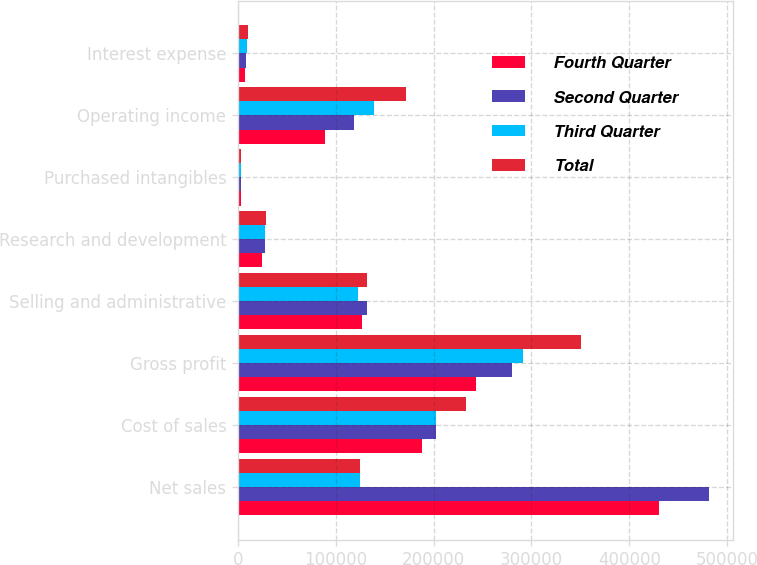<chart> <loc_0><loc_0><loc_500><loc_500><stacked_bar_chart><ecel><fcel>Net sales<fcel>Cost of sales<fcel>Gross profit<fcel>Selling and administrative<fcel>Research and development<fcel>Purchased intangibles<fcel>Operating income<fcel>Interest expense<nl><fcel>Fourth Quarter<fcel>430508<fcel>187719<fcel>242789<fcel>126635<fcel>24746<fcel>2647<fcel>88761<fcel>7489<nl><fcel>Second Quarter<fcel>481801<fcel>201853<fcel>279948<fcel>131930<fcel>26977<fcel>2646<fcel>118395<fcel>7971<nl><fcel>Third Quarter<fcel>124430<fcel>202222<fcel>290943<fcel>122226<fcel>27279<fcel>2725<fcel>138713<fcel>9062<nl><fcel>Total<fcel>124430<fcel>233119<fcel>350751<fcel>131916<fcel>28724<fcel>2616<fcel>172039<fcel>9669<nl></chart> 